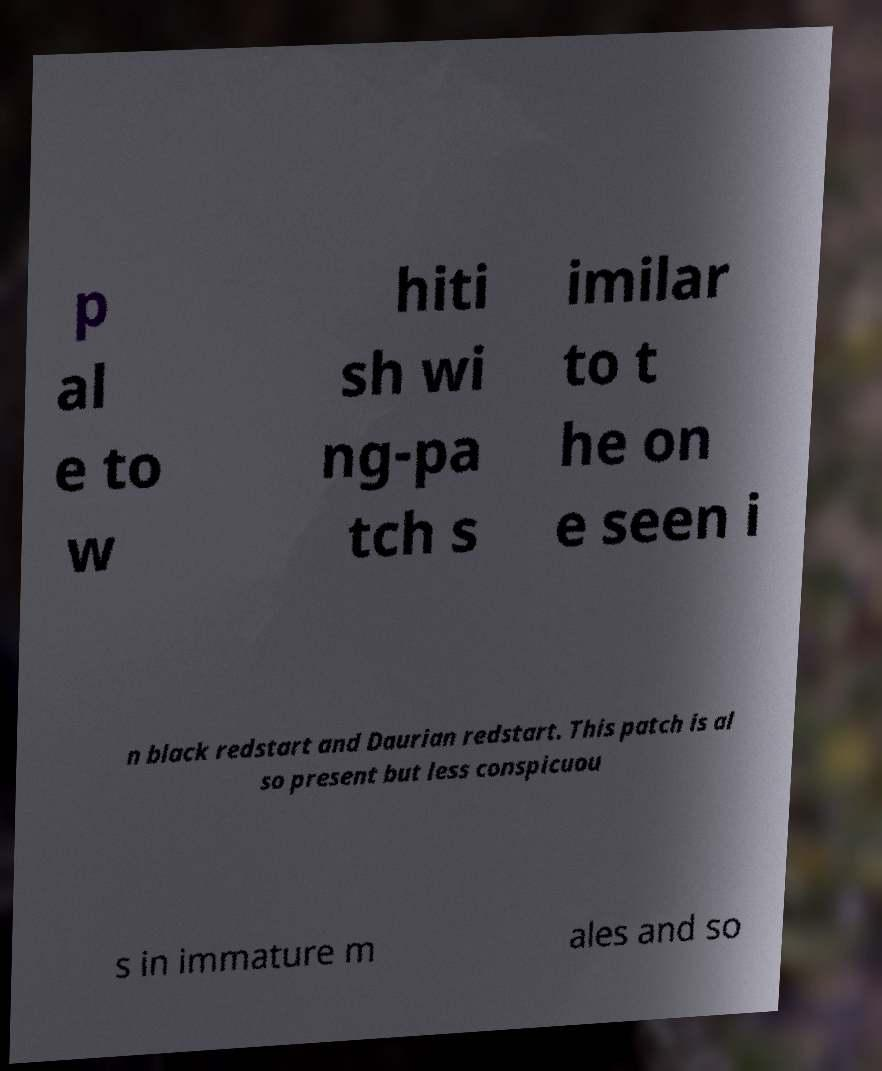Can you read and provide the text displayed in the image?This photo seems to have some interesting text. Can you extract and type it out for me? p al e to w hiti sh wi ng-pa tch s imilar to t he on e seen i n black redstart and Daurian redstart. This patch is al so present but less conspicuou s in immature m ales and so 